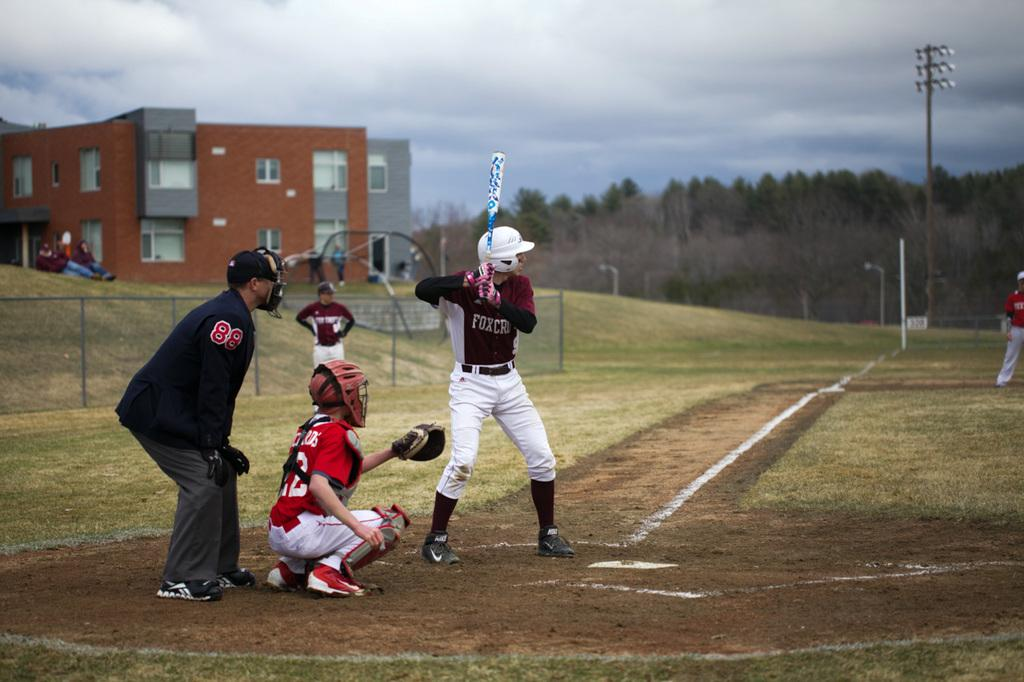<image>
Provide a brief description of the given image. Batter wearing the number 9 waits for a pitch. 